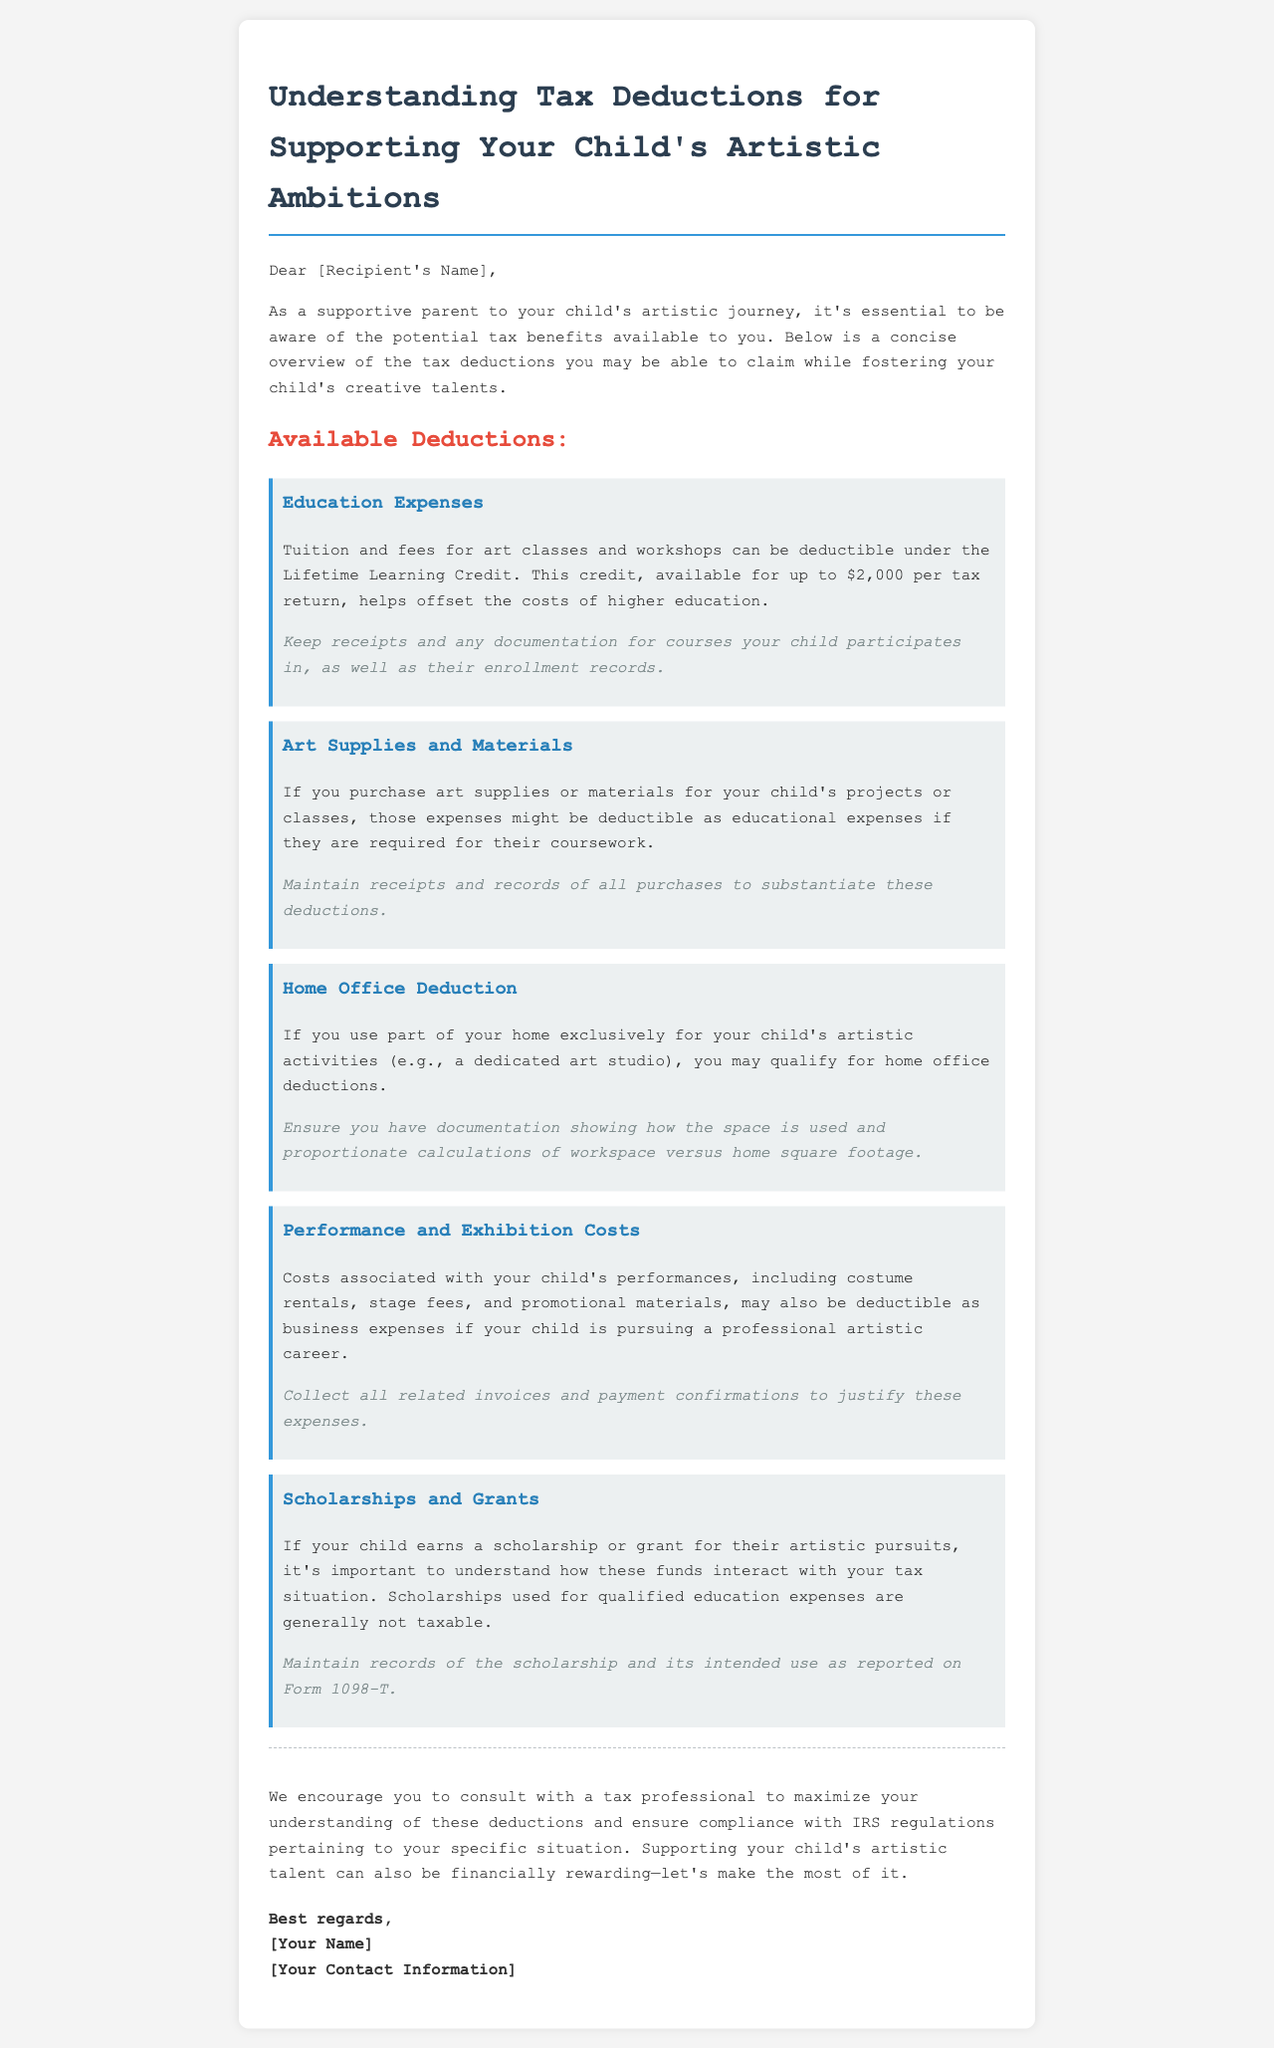What is the title of the document? The title of the document is included in the header and is "Tax Deductions for Supporting Your Child's Artistic Ambitions."
Answer: Tax Deductions for Supporting Your Child's Artistic Ambitions What is the maximum amount for the Lifetime Learning Credit? The document states that the Lifetime Learning Credit helps offset the costs of higher education for up to $2,000 per tax return.
Answer: $2,000 Which expenses are potentially deductible for educational art supplies? The document mentions that art supplies or materials purchased for your child's projects or classes can be deductible as educational expenses.
Answer: Educational expenses What must you maintain to substantiate deductions for art supplies? The document states you should maintain receipts and records of all purchases to substantiate these deductions.
Answer: Receipts and records What do you need to document for the Home Office Deduction? The document indicates that you need documentation showing how the space is used and proportionate calculations of workspace versus home square footage.
Answer: Documentation How can costs associated with performances be categorized for deductions? The document outlines that costs associated with performances may be deductible as business expenses if your child is pursuing a professional artistic career.
Answer: Business expenses What is recommended for maximizing understanding of these deductions? It is stated in the document that consulting with a tax professional is recommended to maximize understanding of deductions and ensure compliance with IRS regulations.
Answer: Consulting a tax professional What type of financial support may not be taxable when related to education? The document mentions that scholarships used for qualified education expenses are generally not taxable.
Answer: Scholarships 